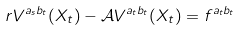Convert formula to latex. <formula><loc_0><loc_0><loc_500><loc_500>r V ^ { a _ { s } b _ { t } } ( X _ { t } ) - \mathcal { A } V ^ { a _ { t } b _ { t } } ( X _ { t } ) = f ^ { a _ { t } b _ { t } }</formula> 